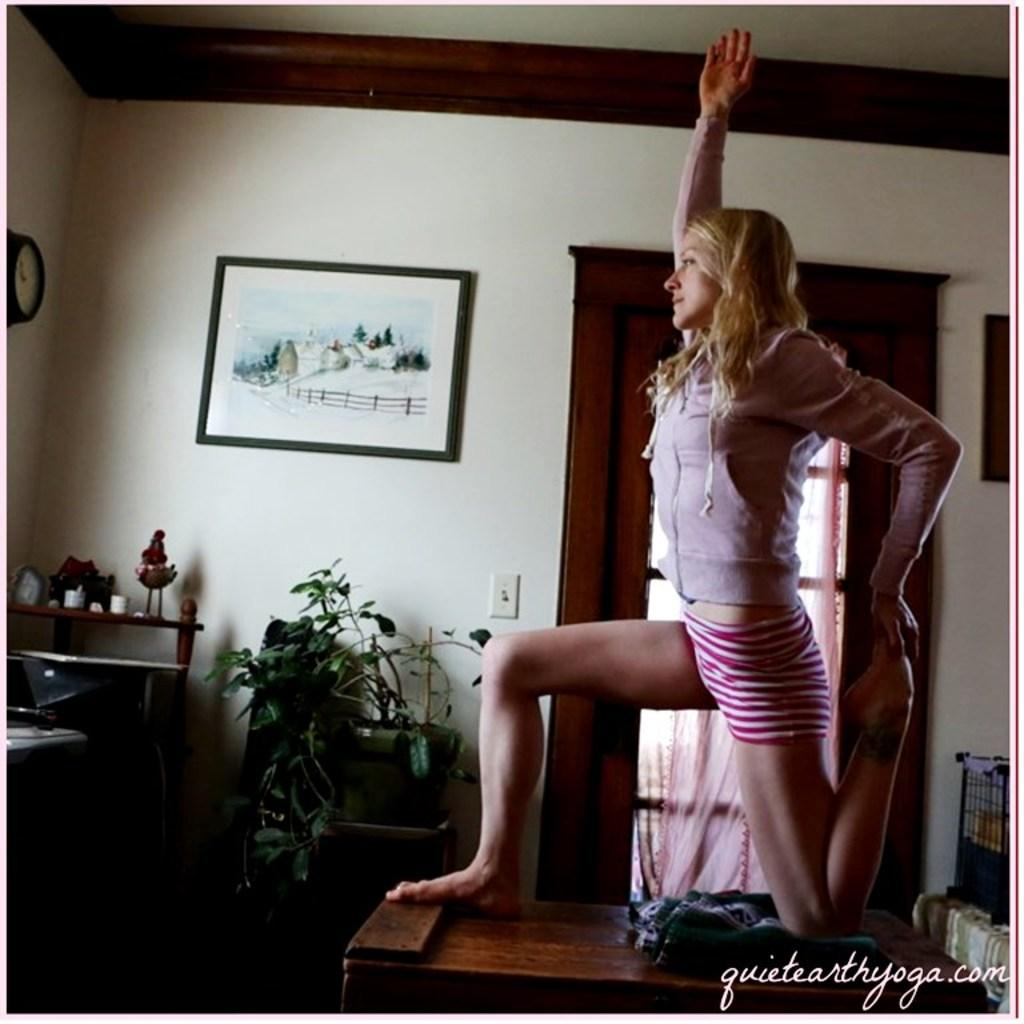What color is the wall in the image? The wall in the image is white. What objects can be seen on the wall? There is a photo frame and a clock on the wall in the image. What piece of furniture is present in the image? There is a table in the image. What type of plant is visible in the image? There is a plant in the image. Who is present in the image? There is a woman in the image. What color is the curtain in the image? The curtain in the image is pink. Can you see any boats in the harbor in the image? There is no harbor or boats present in the image. What type of trick is the woman performing in the image? There is no trick being performed in the image; the woman is simply present. 